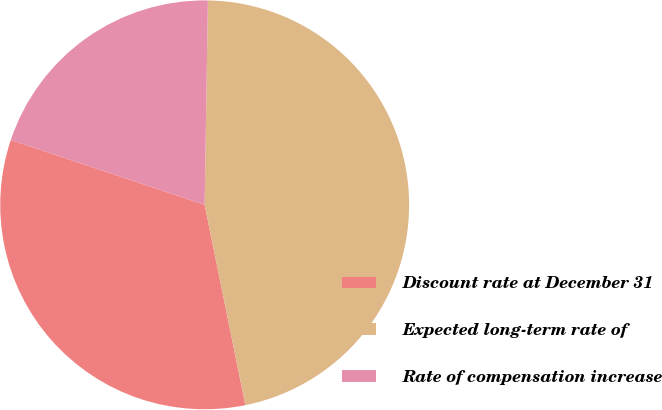<chart> <loc_0><loc_0><loc_500><loc_500><pie_chart><fcel>Discount rate at December 31<fcel>Expected long-term rate of<fcel>Rate of compensation increase<nl><fcel>33.33%<fcel>46.55%<fcel>20.11%<nl></chart> 